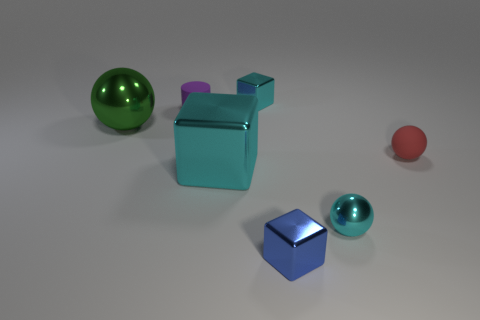Is the number of cyan spheres that are behind the large cyan metallic thing greater than the number of purple things?
Ensure brevity in your answer.  No. What shape is the small thing that is behind the tiny red rubber ball and on the right side of the cylinder?
Offer a terse response. Cube. Does the cyan metallic sphere have the same size as the purple rubber cylinder?
Ensure brevity in your answer.  Yes. What number of metal balls are in front of the big green metallic ball?
Provide a short and direct response. 1. Are there an equal number of cylinders behind the cylinder and green metal spheres that are to the right of the big cyan metallic object?
Your answer should be compact. Yes. There is a cyan metal thing right of the tiny cyan block; does it have the same shape as the small blue metal object?
Provide a succinct answer. No. Are there any other things that have the same material as the big cyan object?
Give a very brief answer. Yes. Is the size of the green ball the same as the rubber thing that is on the right side of the tiny blue metallic object?
Your answer should be very brief. No. What number of other things are there of the same color as the small metal sphere?
Provide a short and direct response. 2. There is a cyan metallic ball; are there any small cyan objects to the left of it?
Make the answer very short. Yes. 